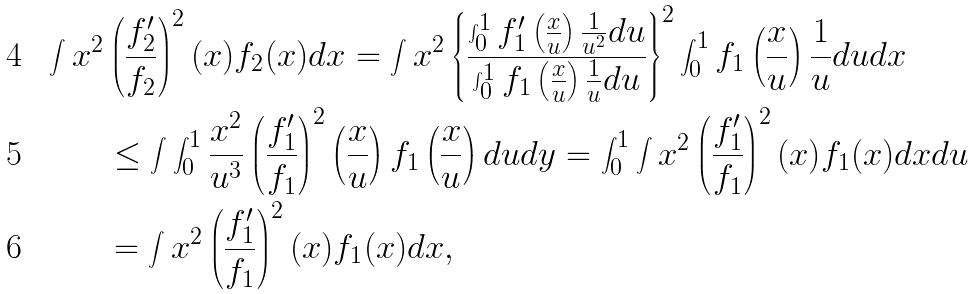<formula> <loc_0><loc_0><loc_500><loc_500>\int x ^ { 2 } & \left ( \frac { f _ { 2 } ^ { \prime } } { f _ { 2 } } \right ) ^ { 2 } ( x ) f _ { 2 } ( x ) d x = \int x ^ { 2 } \left \{ \frac { \int _ { 0 } ^ { 1 } f _ { 1 } ^ { \prime } \left ( \frac { x } { u } \right ) \frac { 1 } { u ^ { 2 } } d u } { \int _ { 0 } ^ { 1 } f _ { 1 } \left ( \frac { x } { u } \right ) \frac { 1 } { u } d u } \right \} ^ { 2 } \int _ { 0 } ^ { 1 } f _ { 1 } \left ( \frac { x } { u } \right ) \frac { 1 } { u } d u d x \\ & \leq \int \int _ { 0 } ^ { 1 } \frac { x ^ { 2 } } { u ^ { 3 } } \left ( \frac { f _ { 1 } ^ { \prime } } { f _ { 1 } } \right ) ^ { 2 } \left ( \frac { x } { u } \right ) f _ { 1 } \left ( \frac { x } { u } \right ) d u d y = \int _ { 0 } ^ { 1 } \int x ^ { 2 } \left ( \frac { f _ { 1 } ^ { \prime } } { f _ { 1 } } \right ) ^ { 2 } ( x ) f _ { 1 } ( x ) d x d u \\ & = \int x ^ { 2 } \left ( \frac { f _ { 1 } ^ { \prime } } { f _ { 1 } } \right ) ^ { 2 } ( x ) f _ { 1 } ( x ) d x ,</formula> 